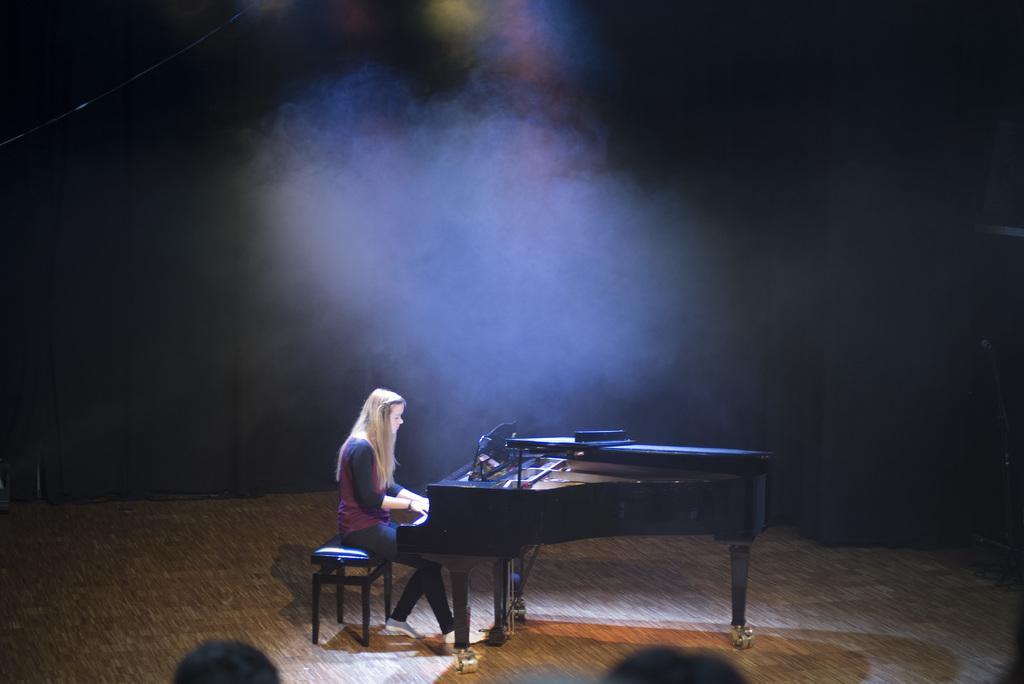In one or two sentences, can you explain what this image depicts? As we can see in the image there is a woman sitting on bench and playing musical keyboard. 